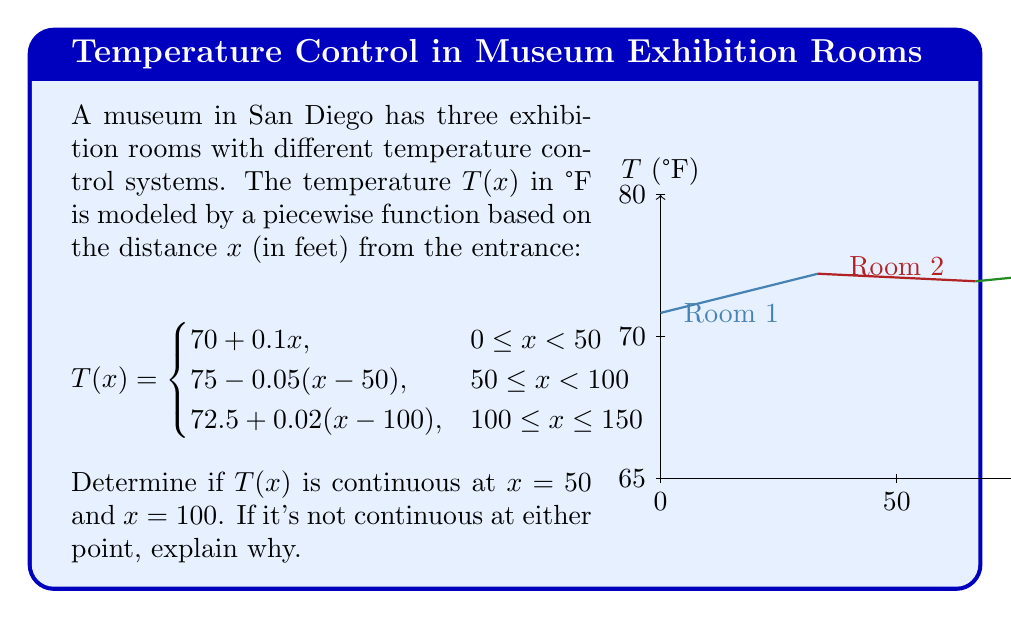Teach me how to tackle this problem. To determine if $T(x)$ is continuous at $x = 50$ and $x = 100$, we need to check three conditions at each point:
1. The function is defined at the point.
2. The limit of the function as we approach the point from both sides exists.
3. The limit equals the function value at that point.

For $x = 50$:
1. $T(50)$ is defined in both pieces of the function.
2. Left limit: $\lim_{x \to 50^-} T(x) = 70 + 0.1(50) = 75$
   Right limit: $\lim_{x \to 50^+} T(x) = 75 - 0.05(50-50) = 75$
3. $T(50) = 75$ (using either piece of the function)

All three conditions are met, so $T(x)$ is continuous at $x = 50$.

For $x = 100$:
1. $T(100)$ is defined in both pieces of the function.
2. Left limit: $\lim_{x \to 100^-} T(x) = 75 - 0.05(100-50) = 72.5$
   Right limit: $\lim_{x \to 100^+} T(x) = 72.5 + 0.02(100-100) = 72.5$
3. $T(100) = 72.5$ (using either piece of the function)

All three conditions are met, so $T(x)$ is continuous at $x = 100$.
Answer: $T(x)$ is continuous at both $x = 50$ and $x = 100$. 